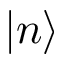<formula> <loc_0><loc_0><loc_500><loc_500>\left | n \right ></formula> 